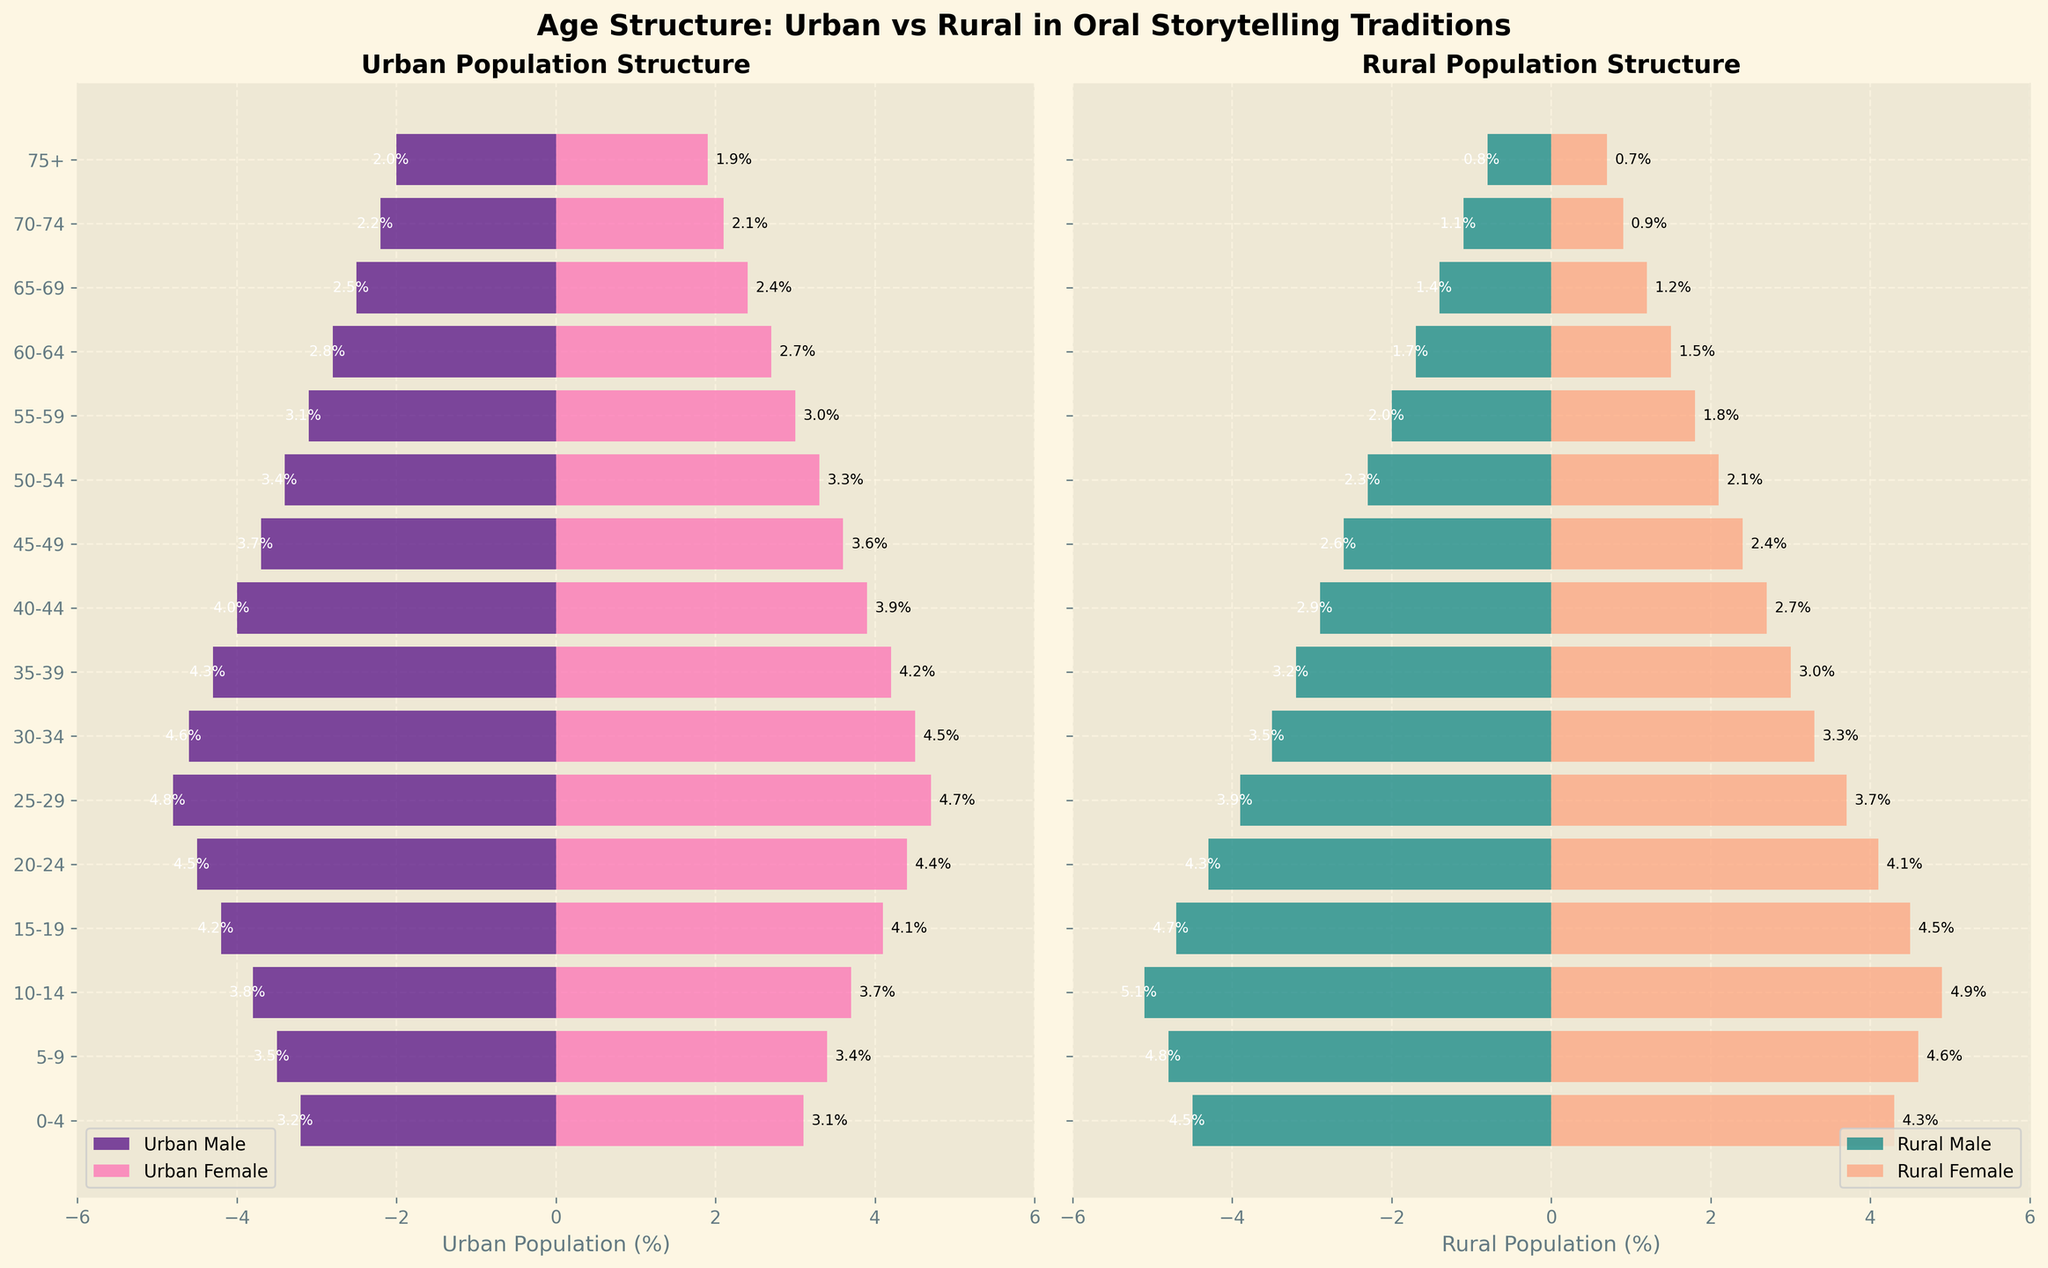How does the population size of urban males aged 0-4 compare to rural males of the same age group? The urban males aged 0-4 represent 3.2% of the urban population, while rural males of the same age group represent 4.5% of the rural population.
Answer: Rural males aged 0-4 are more prevalent What is the age group that has the highest percentage of urban females? From the figure, the age group with the highest percentage of urban females is 25-29 years, showing a value of 4.7%.
Answer: 25-29 years Do rural or urban populations have a higher proportion of individuals aged 70-74? Rural males aged 70-74 make up 1.1% and females 0.9%, whereas urban males are 2.2% and females 2.1%. Thus, urban populations have a higher proportion in this age group.
Answer: Urban What percentage of the urban population is aged 30-34? The percentage of urban males in the 30-34 age group is 4.6%, and for urban females, it is 4.5%. Therefore, the total percentage is 4.6% + 4.5% = 9.1%.
Answer: 9.1% Which gender and population type shows the smallest proportion for the 75+ age group? The rural female population aged 75+ shows the smallest proportion with a percentage of 0.7%.
Answer: Rural Female Compare the urban and rural female populations in the 45-49 age group. Who has a higher percentage? Urban females aged 45-49 have a percentage of 3.6%, whereas rural females in the same age group have a percentage of 2.4%.
Answer: Urban Females What age group shows the highest percent difference between urban males and rural males? Comparing the two populations, the age group 10-14 shows the highest difference with urban males at 3.8% and rural males at 5.1%. Thus, the difference is 5.1% - 3.8% = 1.3%.
Answer: 10-14 What is the total percentage of the rural population in the 50-54 age group? For rural males, it is 2.3% and for rural females, 2.1%. Adding these values gives 2.3% + 2.1% = 4.4%.
Answer: 4.4% Between urban males and rural males, which group has a higher representation in the 20-24 age bracket? Urban males in this bracket stand at 4.5% while rural males are at 4.3%, making urban males slightly higher.
Answer: Urban Males 